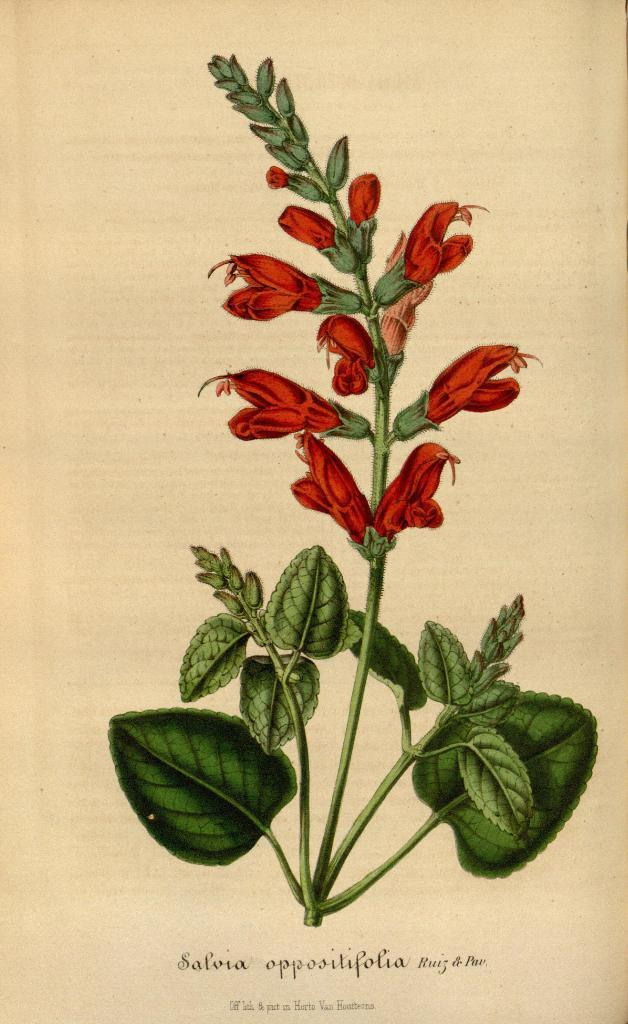What is the main subject of the poster in the image? The poster contains pictures of flowers, leaves, and stems. What other elements are present on the poster besides the images? There is text written at the bottom of the poster. What type of club is mentioned in the text at the bottom of the poster? There is no mention of a club in the text at the bottom of the poster. 